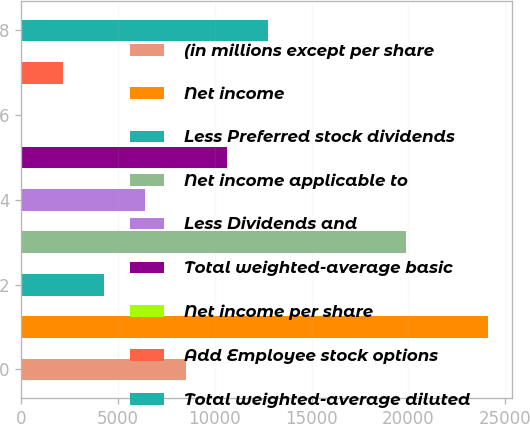<chart> <loc_0><loc_0><loc_500><loc_500><bar_chart><fcel>(in millions except per share<fcel>Net income<fcel>Less Preferred stock dividends<fcel>Net income applicable to<fcel>Less Dividends and<fcel>Total weighted-average basic<fcel>Net income per share<fcel>Add Employee stock options<fcel>Total weighted-average diluted<nl><fcel>8516.74<fcel>24132.8<fcel>4260.98<fcel>19877<fcel>6388.86<fcel>10644.6<fcel>5.22<fcel>2133.1<fcel>12772.5<nl></chart> 